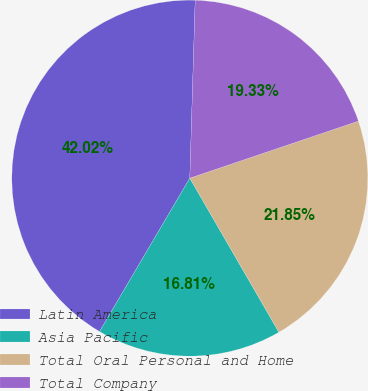<chart> <loc_0><loc_0><loc_500><loc_500><pie_chart><fcel>Latin America<fcel>Asia Pacific<fcel>Total Oral Personal and Home<fcel>Total Company<nl><fcel>42.02%<fcel>16.81%<fcel>21.85%<fcel>19.33%<nl></chart> 